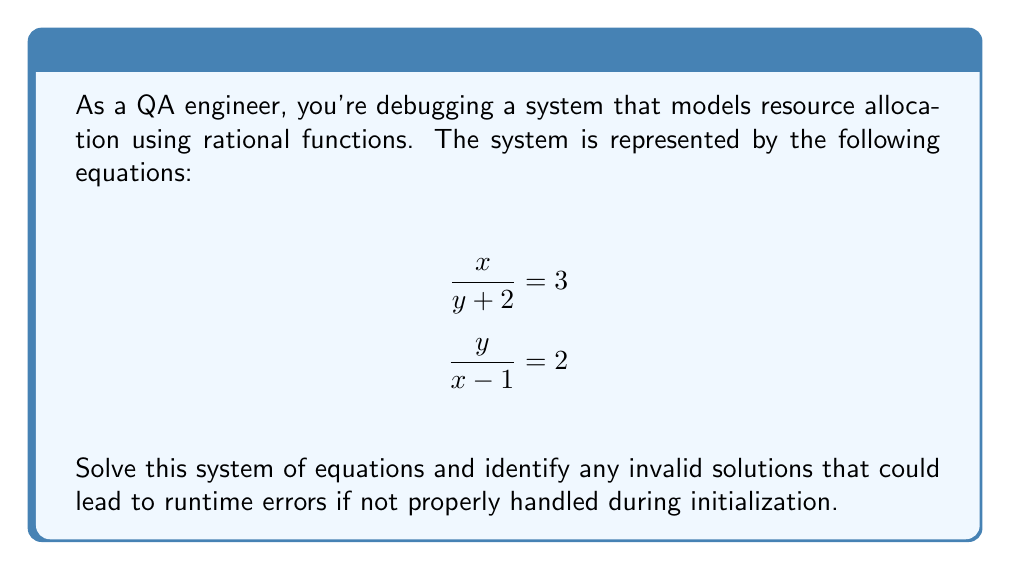Give your solution to this math problem. Let's solve this system of equations step by step:

1) From the first equation: $\frac{x}{y + 2} = 3$
   Multiply both sides by $(y + 2)$:
   $x = 3(y + 2) = 3y + 6$

2) From the second equation: $\frac{y}{x - 1} = 2$
   Multiply both sides by $(x - 1)$:
   $y = 2(x - 1) = 2x - 2$

3) Substitute the expression for $x$ from step 1 into the equation from step 2:
   $y = 2(3y + 6 - 1) = 2(3y + 5) = 6y + 10$

4) Solve for $y$:
   $y = 6y + 10$
   $-5y = 10$
   $y = -2$

5) Substitute $y = -2$ back into the equation from step 1 to find $x$:
   $x = 3(-2 + 2) = 3(0) = 0$

6) Check for invalid solutions:
   - For the first equation $\frac{x}{y + 2} = 3$, $y + 2$ must not be zero.
     With $y = -2$, $y + 2 = 0$, which makes this solution invalid.
   - For the second equation $\frac{y}{x - 1} = 2$, $x - 1$ must not be zero.
     With $x = 0$, $x - 1 = -1$, which is valid.

Therefore, the solution $(x, y) = (0, -2)$ is invalid due to a division by zero in the first equation. This highlights the importance of proper initialization and error handling in the system to prevent runtime errors.
Answer: The system has no valid solution. The apparent solution $(0, -2)$ leads to division by zero. 